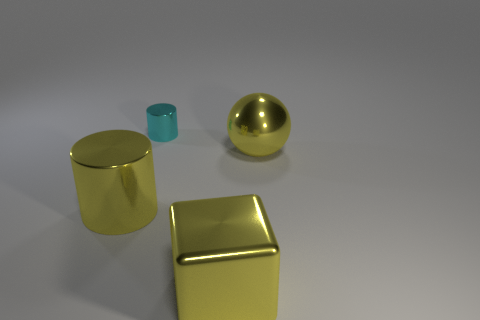Add 1 large metal blocks. How many objects exist? 5 Subtract all blocks. How many objects are left? 3 Add 4 shiny objects. How many shiny objects are left? 8 Add 1 big green shiny things. How many big green shiny things exist? 1 Subtract 0 blue cylinders. How many objects are left? 4 Subtract all big yellow rubber objects. Subtract all large yellow spheres. How many objects are left? 3 